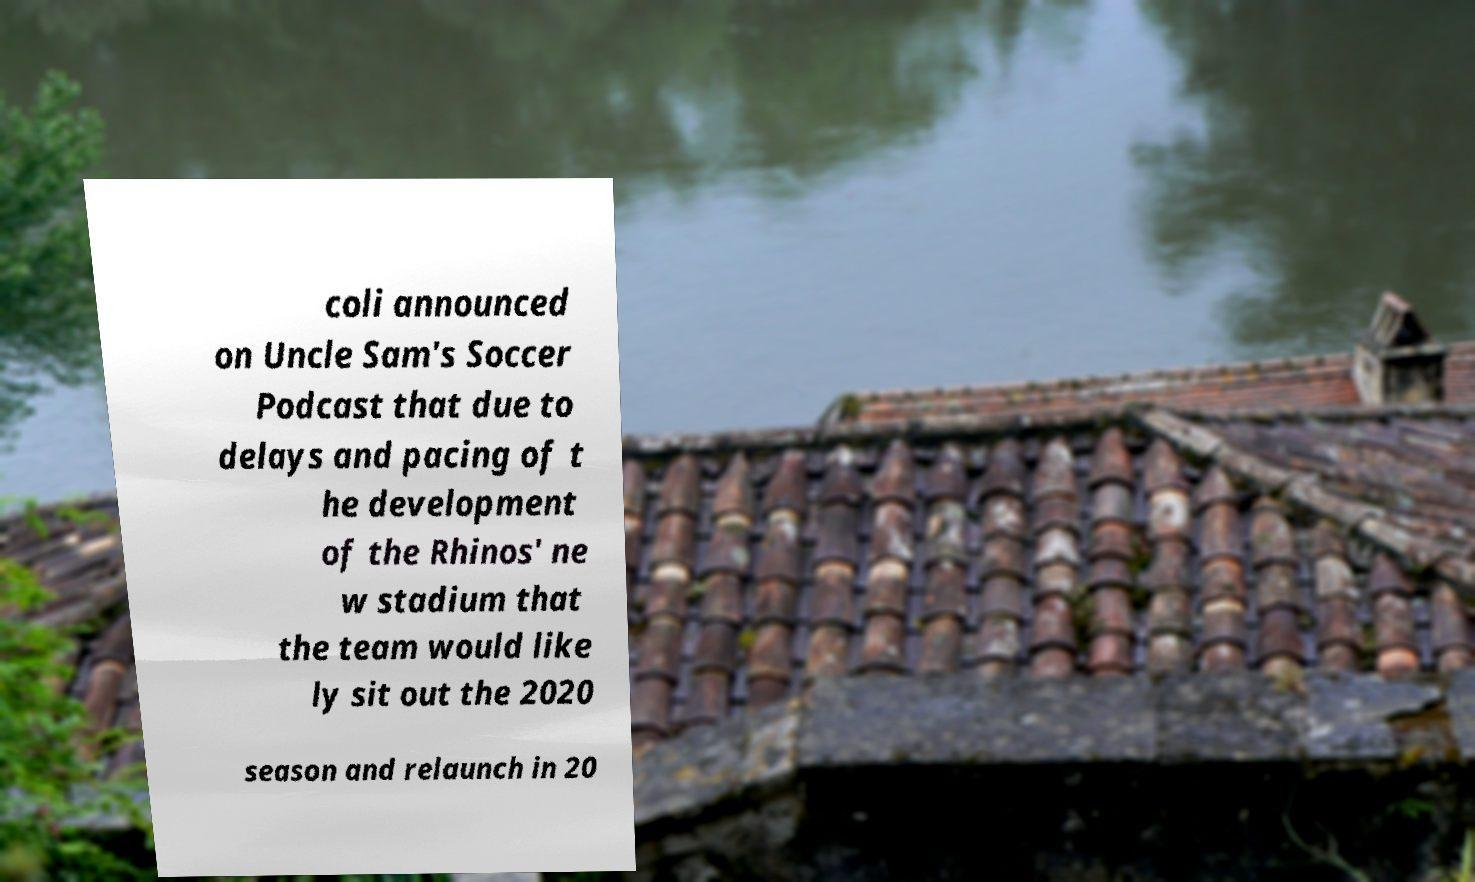Could you assist in decoding the text presented in this image and type it out clearly? coli announced on Uncle Sam's Soccer Podcast that due to delays and pacing of t he development of the Rhinos' ne w stadium that the team would like ly sit out the 2020 season and relaunch in 20 